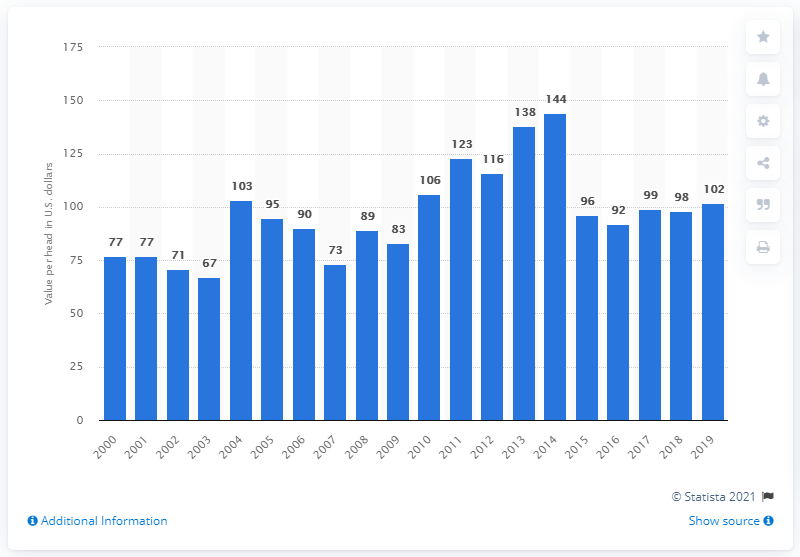Outline some significant characteristics in this image. In 2015, the average head value of a hog or pig in the United States was approximately $96. 